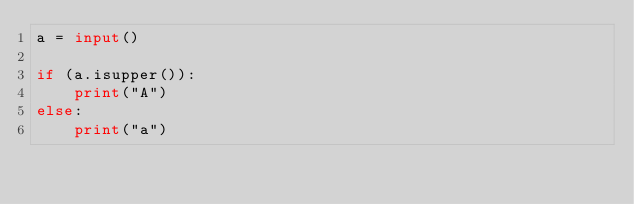<code> <loc_0><loc_0><loc_500><loc_500><_Python_>a = input()

if (a.isupper()):
    print("A")
else:
    print("a")</code> 